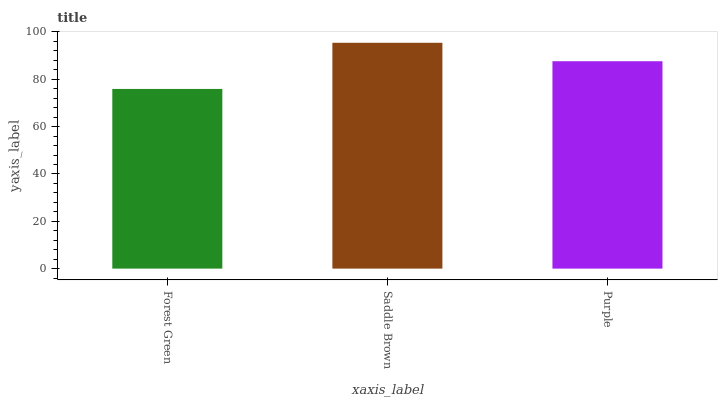Is Forest Green the minimum?
Answer yes or no. Yes. Is Saddle Brown the maximum?
Answer yes or no. Yes. Is Purple the minimum?
Answer yes or no. No. Is Purple the maximum?
Answer yes or no. No. Is Saddle Brown greater than Purple?
Answer yes or no. Yes. Is Purple less than Saddle Brown?
Answer yes or no. Yes. Is Purple greater than Saddle Brown?
Answer yes or no. No. Is Saddle Brown less than Purple?
Answer yes or no. No. Is Purple the high median?
Answer yes or no. Yes. Is Purple the low median?
Answer yes or no. Yes. Is Saddle Brown the high median?
Answer yes or no. No. Is Forest Green the low median?
Answer yes or no. No. 